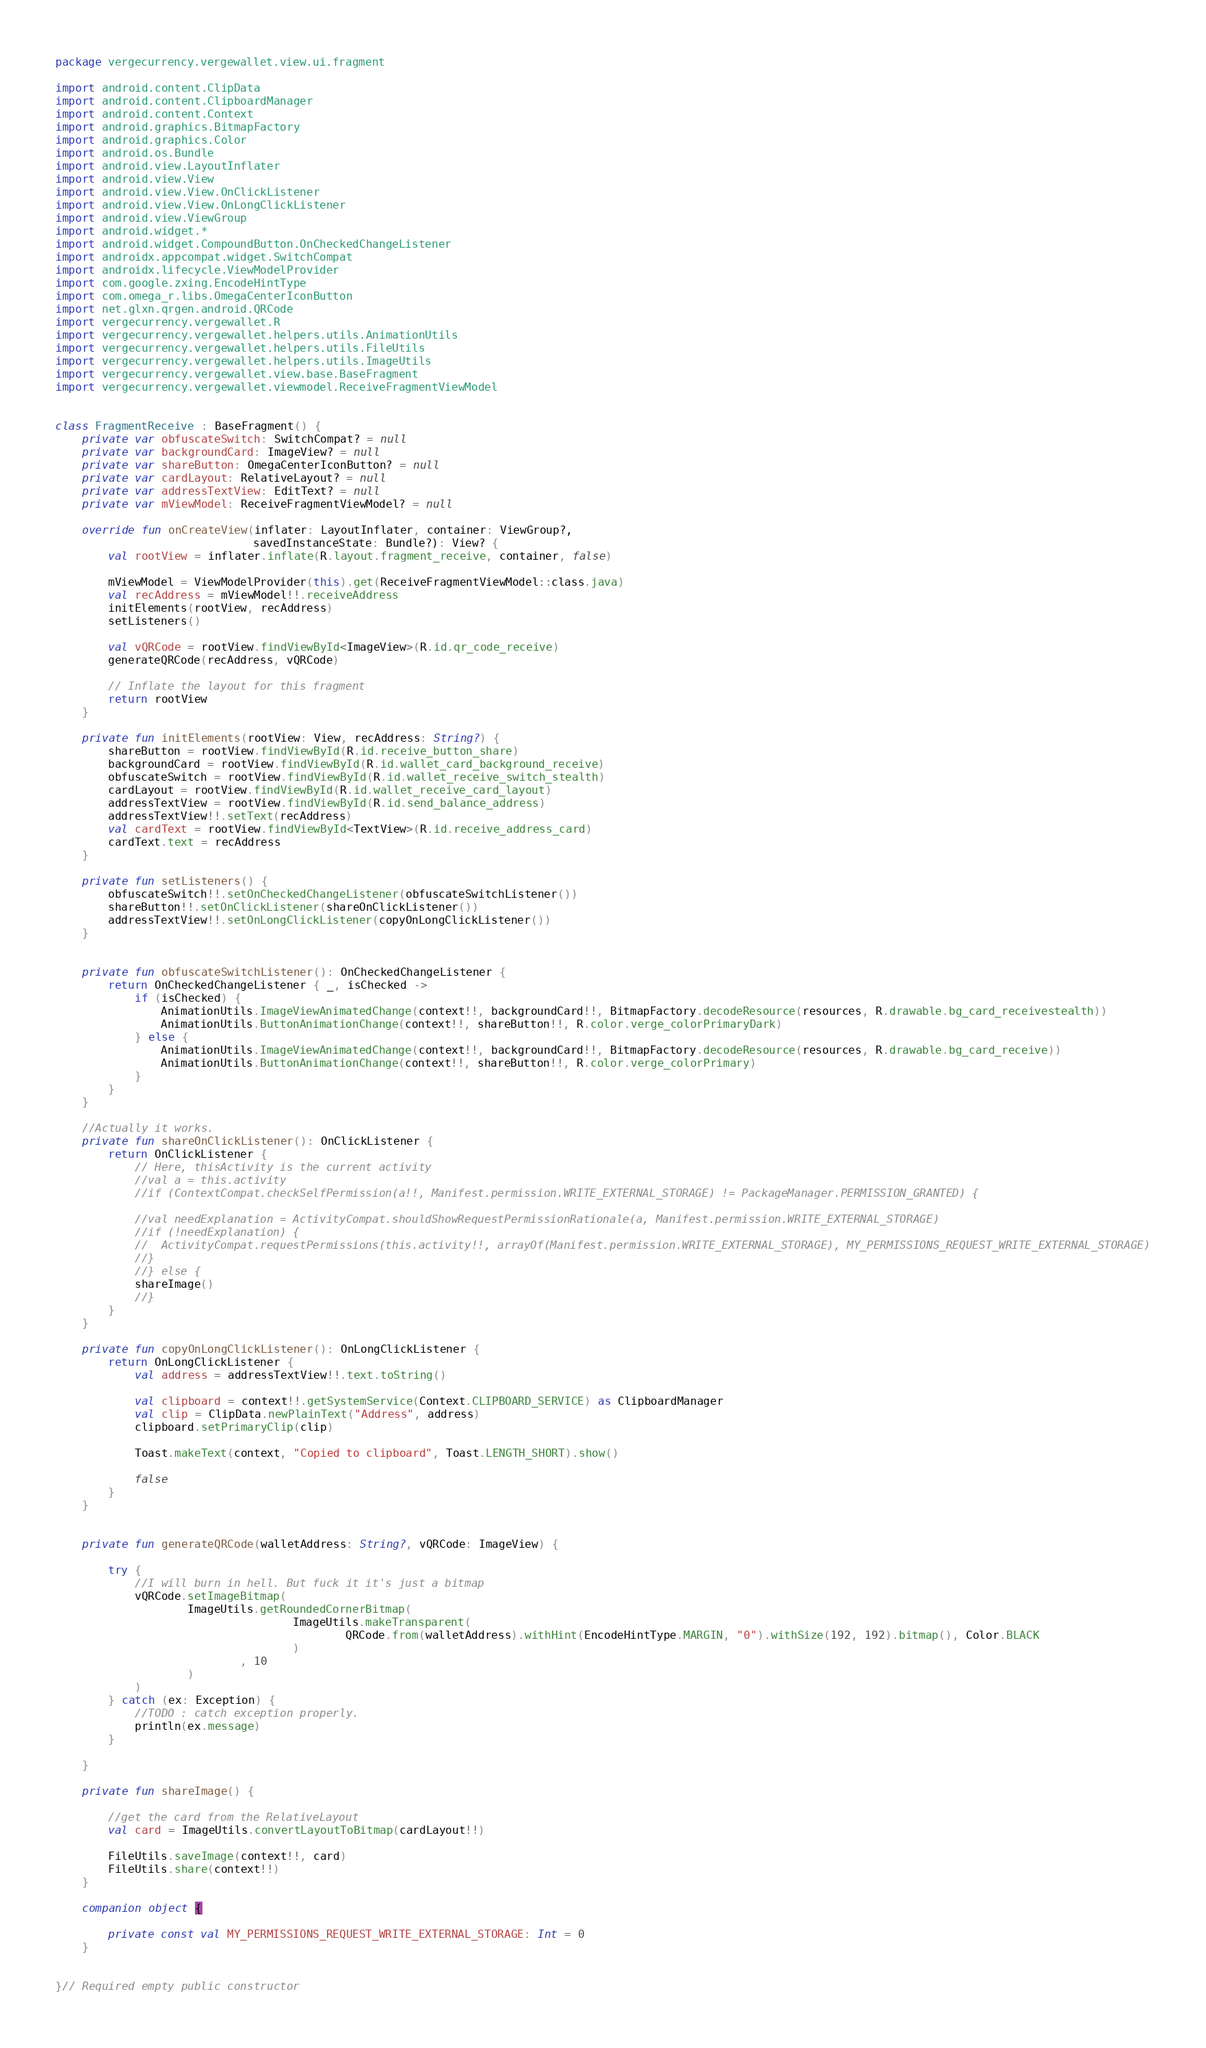<code> <loc_0><loc_0><loc_500><loc_500><_Kotlin_>package vergecurrency.vergewallet.view.ui.fragment

import android.content.ClipData
import android.content.ClipboardManager
import android.content.Context
import android.graphics.BitmapFactory
import android.graphics.Color
import android.os.Bundle
import android.view.LayoutInflater
import android.view.View
import android.view.View.OnClickListener
import android.view.View.OnLongClickListener
import android.view.ViewGroup
import android.widget.*
import android.widget.CompoundButton.OnCheckedChangeListener
import androidx.appcompat.widget.SwitchCompat
import androidx.lifecycle.ViewModelProvider
import com.google.zxing.EncodeHintType
import com.omega_r.libs.OmegaCenterIconButton
import net.glxn.qrgen.android.QRCode
import vergecurrency.vergewallet.R
import vergecurrency.vergewallet.helpers.utils.AnimationUtils
import vergecurrency.vergewallet.helpers.utils.FileUtils
import vergecurrency.vergewallet.helpers.utils.ImageUtils
import vergecurrency.vergewallet.view.base.BaseFragment
import vergecurrency.vergewallet.viewmodel.ReceiveFragmentViewModel


class FragmentReceive : BaseFragment() {
    private var obfuscateSwitch: SwitchCompat? = null
    private var backgroundCard: ImageView? = null
    private var shareButton: OmegaCenterIconButton? = null
    private var cardLayout: RelativeLayout? = null
    private var addressTextView: EditText? = null
    private var mViewModel: ReceiveFragmentViewModel? = null

    override fun onCreateView(inflater: LayoutInflater, container: ViewGroup?,
                              savedInstanceState: Bundle?): View? {
        val rootView = inflater.inflate(R.layout.fragment_receive, container, false)

        mViewModel = ViewModelProvider(this).get(ReceiveFragmentViewModel::class.java)
        val recAddress = mViewModel!!.receiveAddress
        initElements(rootView, recAddress)
        setListeners()

        val vQRCode = rootView.findViewById<ImageView>(R.id.qr_code_receive)
        generateQRCode(recAddress, vQRCode)

        // Inflate the layout for this fragment
        return rootView
    }

    private fun initElements(rootView: View, recAddress: String?) {
        shareButton = rootView.findViewById(R.id.receive_button_share)
        backgroundCard = rootView.findViewById(R.id.wallet_card_background_receive)
        obfuscateSwitch = rootView.findViewById(R.id.wallet_receive_switch_stealth)
        cardLayout = rootView.findViewById(R.id.wallet_receive_card_layout)
        addressTextView = rootView.findViewById(R.id.send_balance_address)
        addressTextView!!.setText(recAddress)
        val cardText = rootView.findViewById<TextView>(R.id.receive_address_card)
        cardText.text = recAddress
    }

    private fun setListeners() {
        obfuscateSwitch!!.setOnCheckedChangeListener(obfuscateSwitchListener())
        shareButton!!.setOnClickListener(shareOnClickListener())
        addressTextView!!.setOnLongClickListener(copyOnLongClickListener())
    }


    private fun obfuscateSwitchListener(): OnCheckedChangeListener {
        return OnCheckedChangeListener { _, isChecked ->
            if (isChecked) {
                AnimationUtils.ImageViewAnimatedChange(context!!, backgroundCard!!, BitmapFactory.decodeResource(resources, R.drawable.bg_card_receivestealth))
                AnimationUtils.ButtonAnimationChange(context!!, shareButton!!, R.color.verge_colorPrimaryDark)
            } else {
                AnimationUtils.ImageViewAnimatedChange(context!!, backgroundCard!!, BitmapFactory.decodeResource(resources, R.drawable.bg_card_receive))
                AnimationUtils.ButtonAnimationChange(context!!, shareButton!!, R.color.verge_colorPrimary)
            }
        }
    }

    //Actually it works.
    private fun shareOnClickListener(): OnClickListener {
        return OnClickListener {
            // Here, thisActivity is the current activity
            //val a = this.activity
            //if (ContextCompat.checkSelfPermission(a!!, Manifest.permission.WRITE_EXTERNAL_STORAGE) != PackageManager.PERMISSION_GRANTED) {

            //val needExplanation = ActivityCompat.shouldShowRequestPermissionRationale(a, Manifest.permission.WRITE_EXTERNAL_STORAGE)
            //if (!needExplanation) {
            //  ActivityCompat.requestPermissions(this.activity!!, arrayOf(Manifest.permission.WRITE_EXTERNAL_STORAGE), MY_PERMISSIONS_REQUEST_WRITE_EXTERNAL_STORAGE)
            //}
            //} else {
            shareImage()
            //}
        }
    }

    private fun copyOnLongClickListener(): OnLongClickListener {
        return OnLongClickListener {
            val address = addressTextView!!.text.toString()

            val clipboard = context!!.getSystemService(Context.CLIPBOARD_SERVICE) as ClipboardManager
            val clip = ClipData.newPlainText("Address", address)
            clipboard.setPrimaryClip(clip)

            Toast.makeText(context, "Copied to clipboard", Toast.LENGTH_SHORT).show()

            false
        }
    }


    private fun generateQRCode(walletAddress: String?, vQRCode: ImageView) {

        try {
            //I will burn in hell. But fuck it it's just a bitmap
            vQRCode.setImageBitmap(
                    ImageUtils.getRoundedCornerBitmap(
                                    ImageUtils.makeTransparent(
                                            QRCode.from(walletAddress).withHint(EncodeHintType.MARGIN, "0").withSize(192, 192).bitmap(), Color.BLACK
                                    )
                            , 10
                    )
            )
        } catch (ex: Exception) {
            //TODO : catch exception properly.
            println(ex.message)
        }

    }

    private fun shareImage() {

        //get the card from the RelativeLayout
        val card = ImageUtils.convertLayoutToBitmap(cardLayout!!)

        FileUtils.saveImage(context!!, card)
        FileUtils.share(context!!)
    }

    companion object {

        private const val MY_PERMISSIONS_REQUEST_WRITE_EXTERNAL_STORAGE: Int = 0
    }


}// Required empty public constructor
</code> 